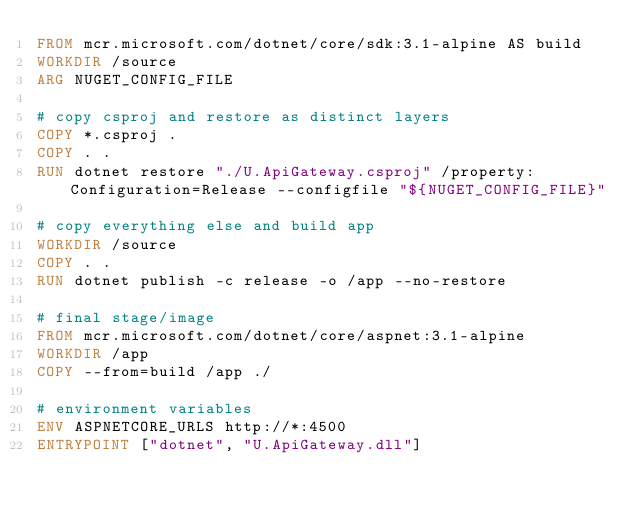Convert code to text. <code><loc_0><loc_0><loc_500><loc_500><_Dockerfile_>FROM mcr.microsoft.com/dotnet/core/sdk:3.1-alpine AS build
WORKDIR /source
ARG NUGET_CONFIG_FILE

# copy csproj and restore as distinct layers
COPY *.csproj .
COPY . .
RUN dotnet restore "./U.ApiGateway.csproj" /property:Configuration=Release --configfile "${NUGET_CONFIG_FILE}"

# copy everything else and build app
WORKDIR /source
COPY . .
RUN dotnet publish -c release -o /app --no-restore

# final stage/image
FROM mcr.microsoft.com/dotnet/core/aspnet:3.1-alpine
WORKDIR /app
COPY --from=build /app ./

# environment variables
ENV ASPNETCORE_URLS http://*:4500
ENTRYPOINT ["dotnet", "U.ApiGateway.dll"]</code> 